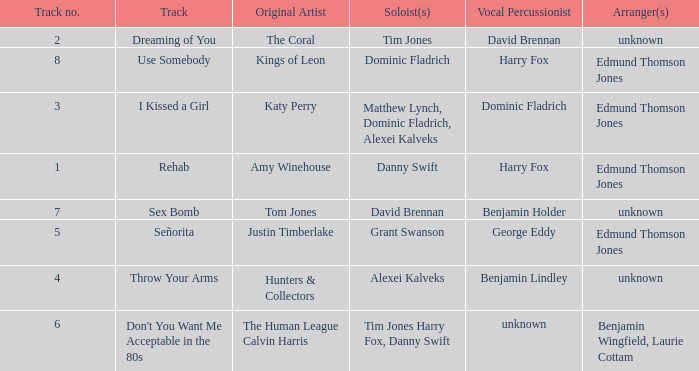Who is the percussionist for The Coral? David Brennan. 